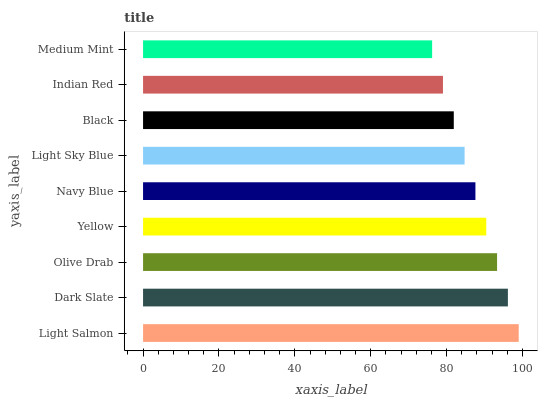Is Medium Mint the minimum?
Answer yes or no. Yes. Is Light Salmon the maximum?
Answer yes or no. Yes. Is Dark Slate the minimum?
Answer yes or no. No. Is Dark Slate the maximum?
Answer yes or no. No. Is Light Salmon greater than Dark Slate?
Answer yes or no. Yes. Is Dark Slate less than Light Salmon?
Answer yes or no. Yes. Is Dark Slate greater than Light Salmon?
Answer yes or no. No. Is Light Salmon less than Dark Slate?
Answer yes or no. No. Is Navy Blue the high median?
Answer yes or no. Yes. Is Navy Blue the low median?
Answer yes or no. Yes. Is Light Salmon the high median?
Answer yes or no. No. Is Olive Drab the low median?
Answer yes or no. No. 